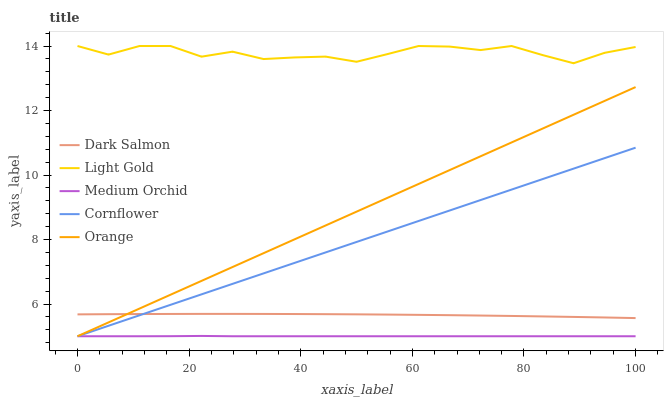Does Cornflower have the minimum area under the curve?
Answer yes or no. No. Does Cornflower have the maximum area under the curve?
Answer yes or no. No. Is Cornflower the smoothest?
Answer yes or no. No. Is Cornflower the roughest?
Answer yes or no. No. Does Light Gold have the lowest value?
Answer yes or no. No. Does Cornflower have the highest value?
Answer yes or no. No. Is Orange less than Light Gold?
Answer yes or no. Yes. Is Light Gold greater than Orange?
Answer yes or no. Yes. Does Orange intersect Light Gold?
Answer yes or no. No. 